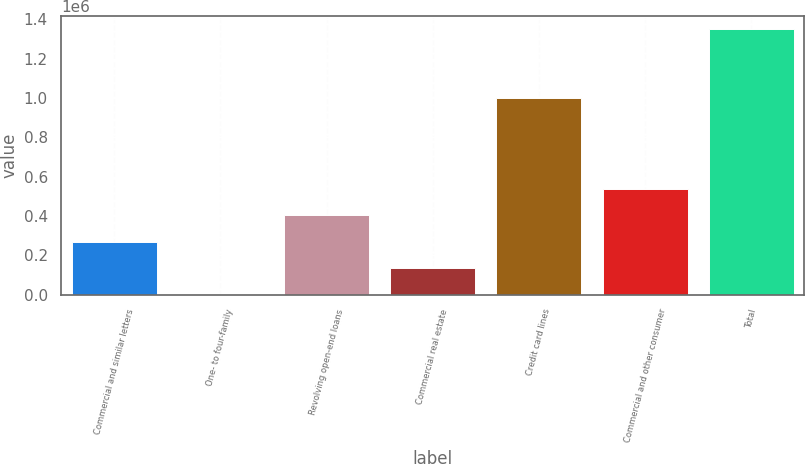<chart> <loc_0><loc_0><loc_500><loc_500><bar_chart><fcel>Commercial and similar letters<fcel>One- to four-family<fcel>Revolving open-end loans<fcel>Commercial real estate<fcel>Credit card lines<fcel>Commercial and other consumer<fcel>Total<nl><fcel>270650<fcel>937<fcel>405506<fcel>135793<fcel>1.00244e+06<fcel>540362<fcel>1.3495e+06<nl></chart> 